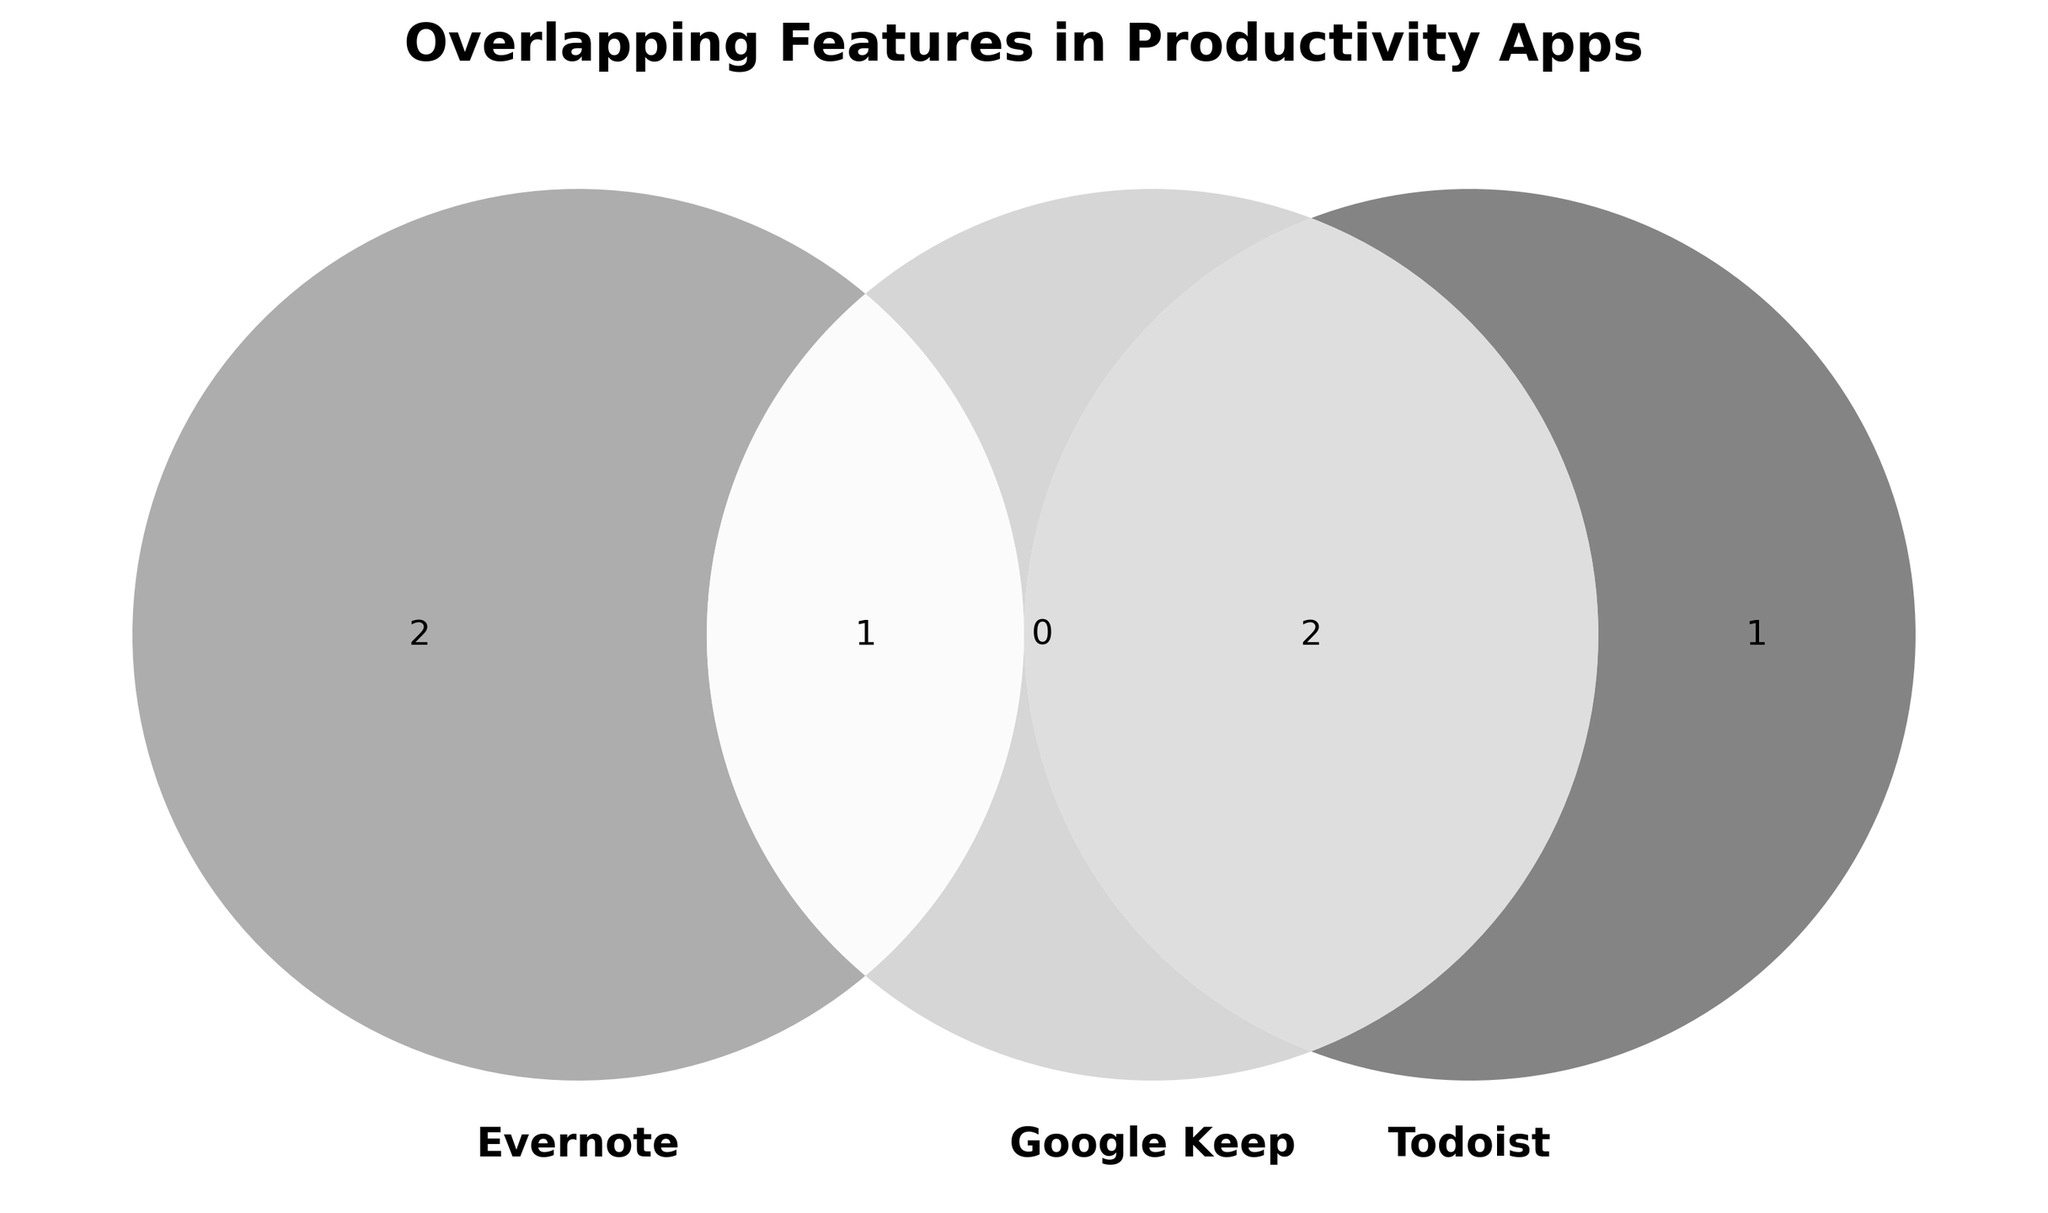What's the title of the Venn Diagram? The title of the figure is typically located at the top. Here, the title is "Overlapping Features in Productivity Apps."
Answer: Overlapping Features in Productivity Apps Which apps have the "Note-taking" feature in common? The common area where the "Note-taking" feature overlaps encompasses Google Keep, Evernote, and Microsoft OneNote.
Answer: Google Keep, Evernote, Microsoft OneNote How many unique features are there in Evernote? You need to count the unique features only in Evernote and the shared features. Evernote has Note-taking, Web clipping, and Document scanning, totaling three unique features.
Answer: 3 Which app has the most overlap with Google Keep? To determine this, examine the overlapping areas. Todoist and Google Keep share both Reminders and Collaboration.
Answer: Todoist Do Any.do and Microsoft OneNote shares any features? Check the overlapping areas between Any.do and Microsoft OneNote. There are no common features between the two apps in the figure.
Answer: No Which feature is common to both Google Keep and Todoist? Identify the section where Google Keep and Todoist overlap. The shared feature is "Reminders."
Answer: Reminders How many features are unique to Todoist? Todoist has Task management unique to itself since Reminders and Collaboration are shared with Google Keep.
Answer: 1 Does Evernote share more features with Google Keep or Microsoft OneNote? Compare the overlapping areas. Evernote shares Note-taking with both Google Keep and Microsoft OneNote, but it shares an additional feature, Web clipping, with Microsoft OneNote.
Answer: Microsoft OneNote What unique feature does Any.do have compared to the other apps? Identify the feature only present in Any.do. The unique feature is Calendar integration.
Answer: Calendar integration 